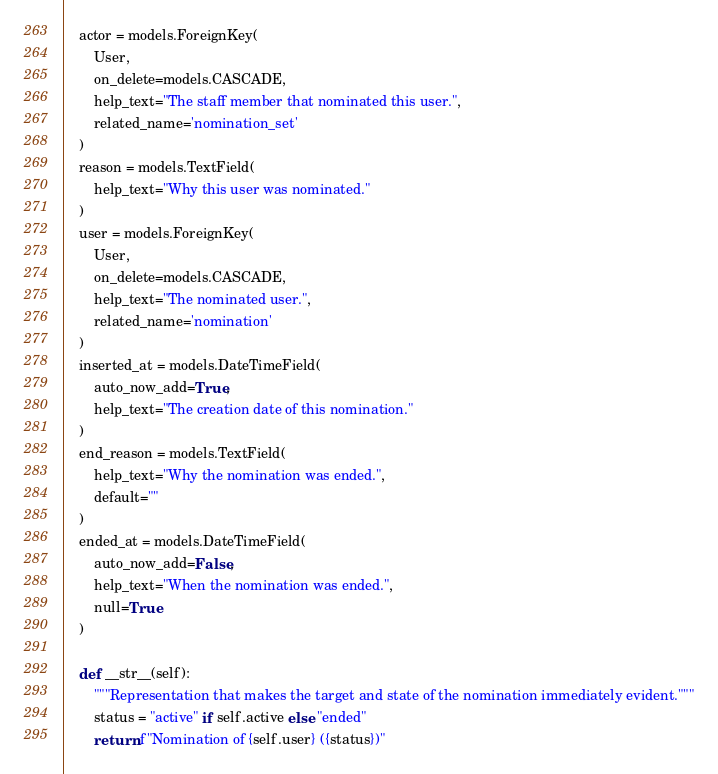<code> <loc_0><loc_0><loc_500><loc_500><_Python_>    actor = models.ForeignKey(
        User,
        on_delete=models.CASCADE,
        help_text="The staff member that nominated this user.",
        related_name='nomination_set'
    )
    reason = models.TextField(
        help_text="Why this user was nominated."
    )
    user = models.ForeignKey(
        User,
        on_delete=models.CASCADE,
        help_text="The nominated user.",
        related_name='nomination'
    )
    inserted_at = models.DateTimeField(
        auto_now_add=True,
        help_text="The creation date of this nomination."
    )
    end_reason = models.TextField(
        help_text="Why the nomination was ended.",
        default=""
    )
    ended_at = models.DateTimeField(
        auto_now_add=False,
        help_text="When the nomination was ended.",
        null=True
    )

    def __str__(self):
        """Representation that makes the target and state of the nomination immediately evident."""
        status = "active" if self.active else "ended"
        return f"Nomination of {self.user} ({status})"
</code> 